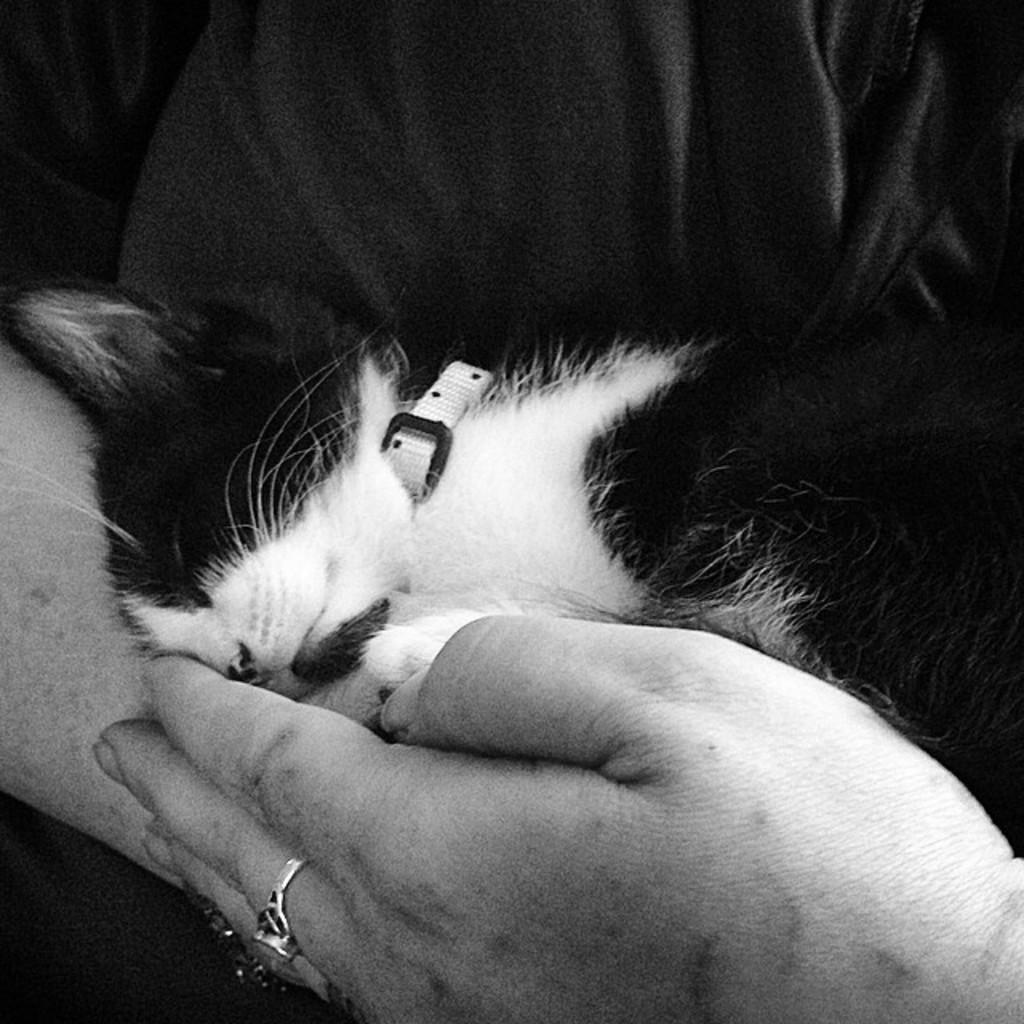What is the main subject of the image? There is a person in the image. What is the person holding in the image? The person is holding a kitten. What type of meal is being prepared in the image? There is no meal preparation visible in the image; it features a person holding a kitten. What kind of shock can be seen in the image? There is no shock or electrical activity present in the image; it features a person holding a kitten. 